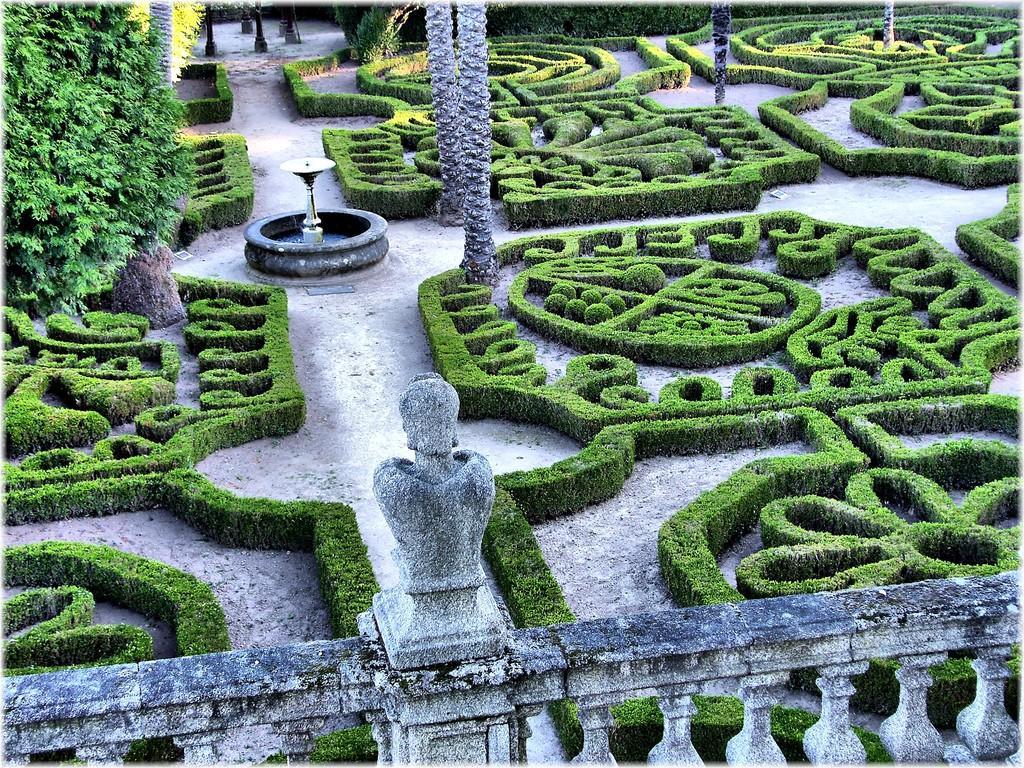Could you give a brief overview of what you see in this image? In this image I can see the rail. I can see the plants and the trees. In the middle I can see the fountain. 